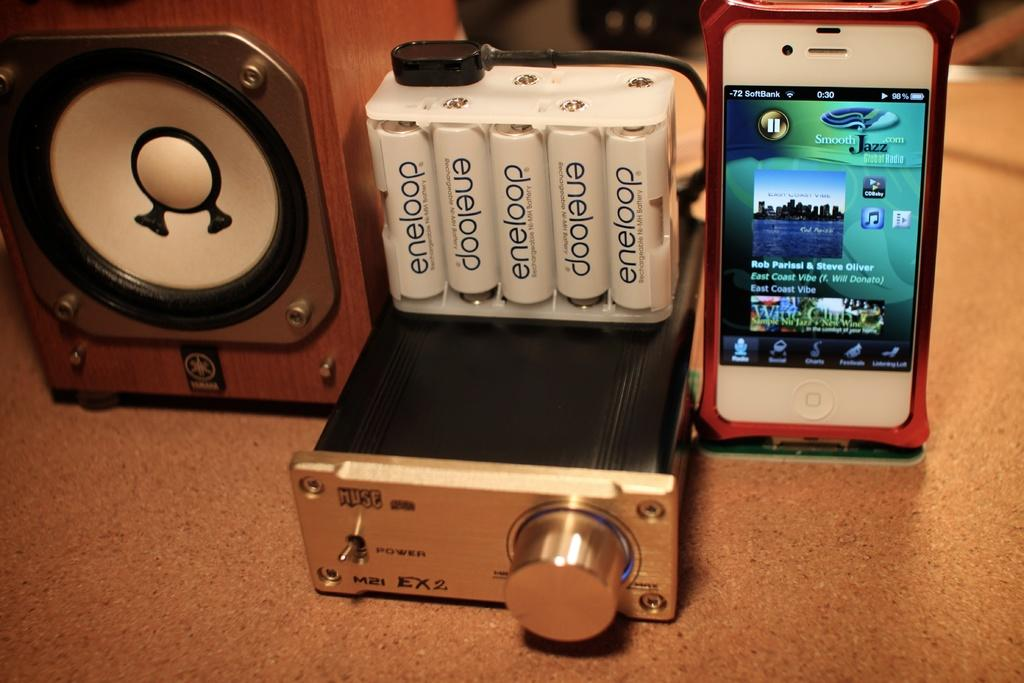<image>
Provide a brief description of the given image. A cell phone sits on one side of an eneloop charging device and a speaker sits on the other side. 